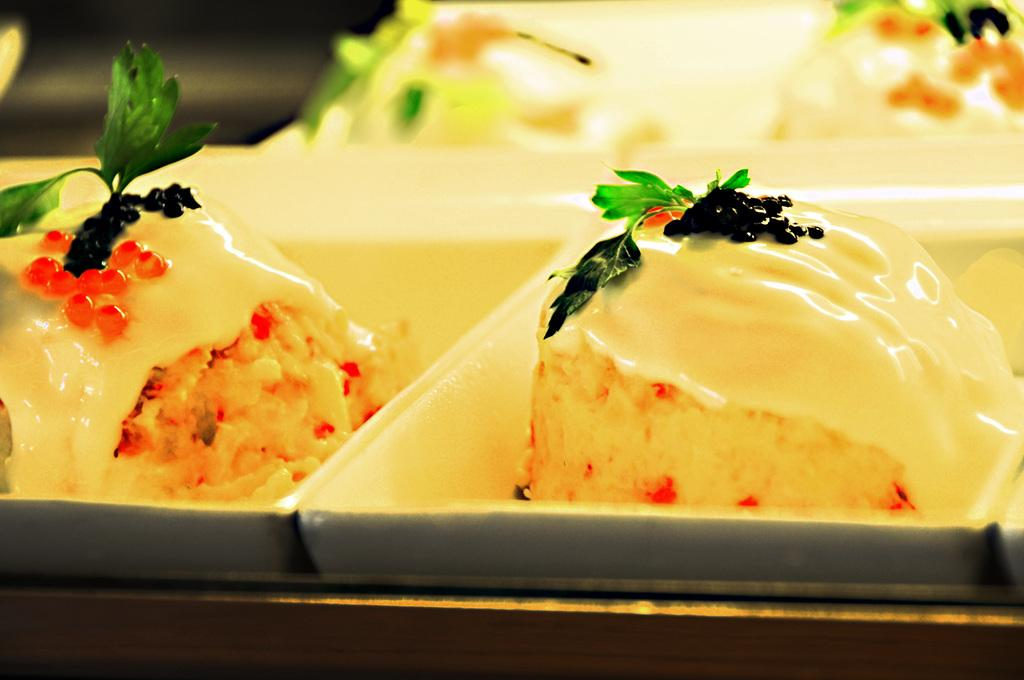What is placed on the tray in the image? There are food items placed on a tray in the image. How are the food items decorated or presented? The food items are garnished with leaves. Can you describe the background of the image? The background of the image is blurred. How many chairs can be seen in the image? There are no chairs visible in the image. What type of hearing aid is being used by the person in the image? There is no person or hearing aid present in the image. 